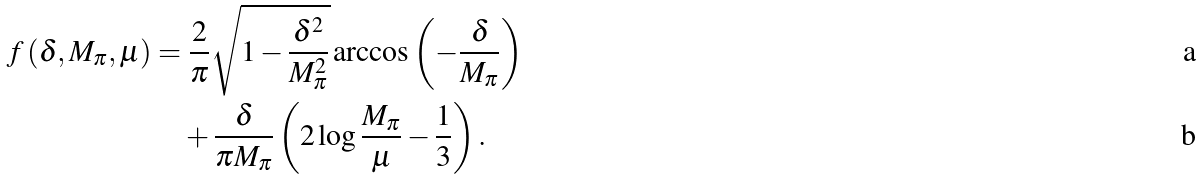Convert formula to latex. <formula><loc_0><loc_0><loc_500><loc_500>f \left ( \delta , M _ { \pi } , \mu \right ) & = \frac { 2 } { \pi } \sqrt { 1 - \frac { \delta ^ { 2 } } { M _ { \pi } ^ { 2 } } } \arccos \left ( - \frac { \delta } { M _ { \pi } } \right ) \\ & \quad + \frac { \delta } { \pi M _ { \pi } } \left ( 2 \log \frac { M _ { \pi } } { \mu } - \frac { 1 } { 3 } \right ) .</formula> 